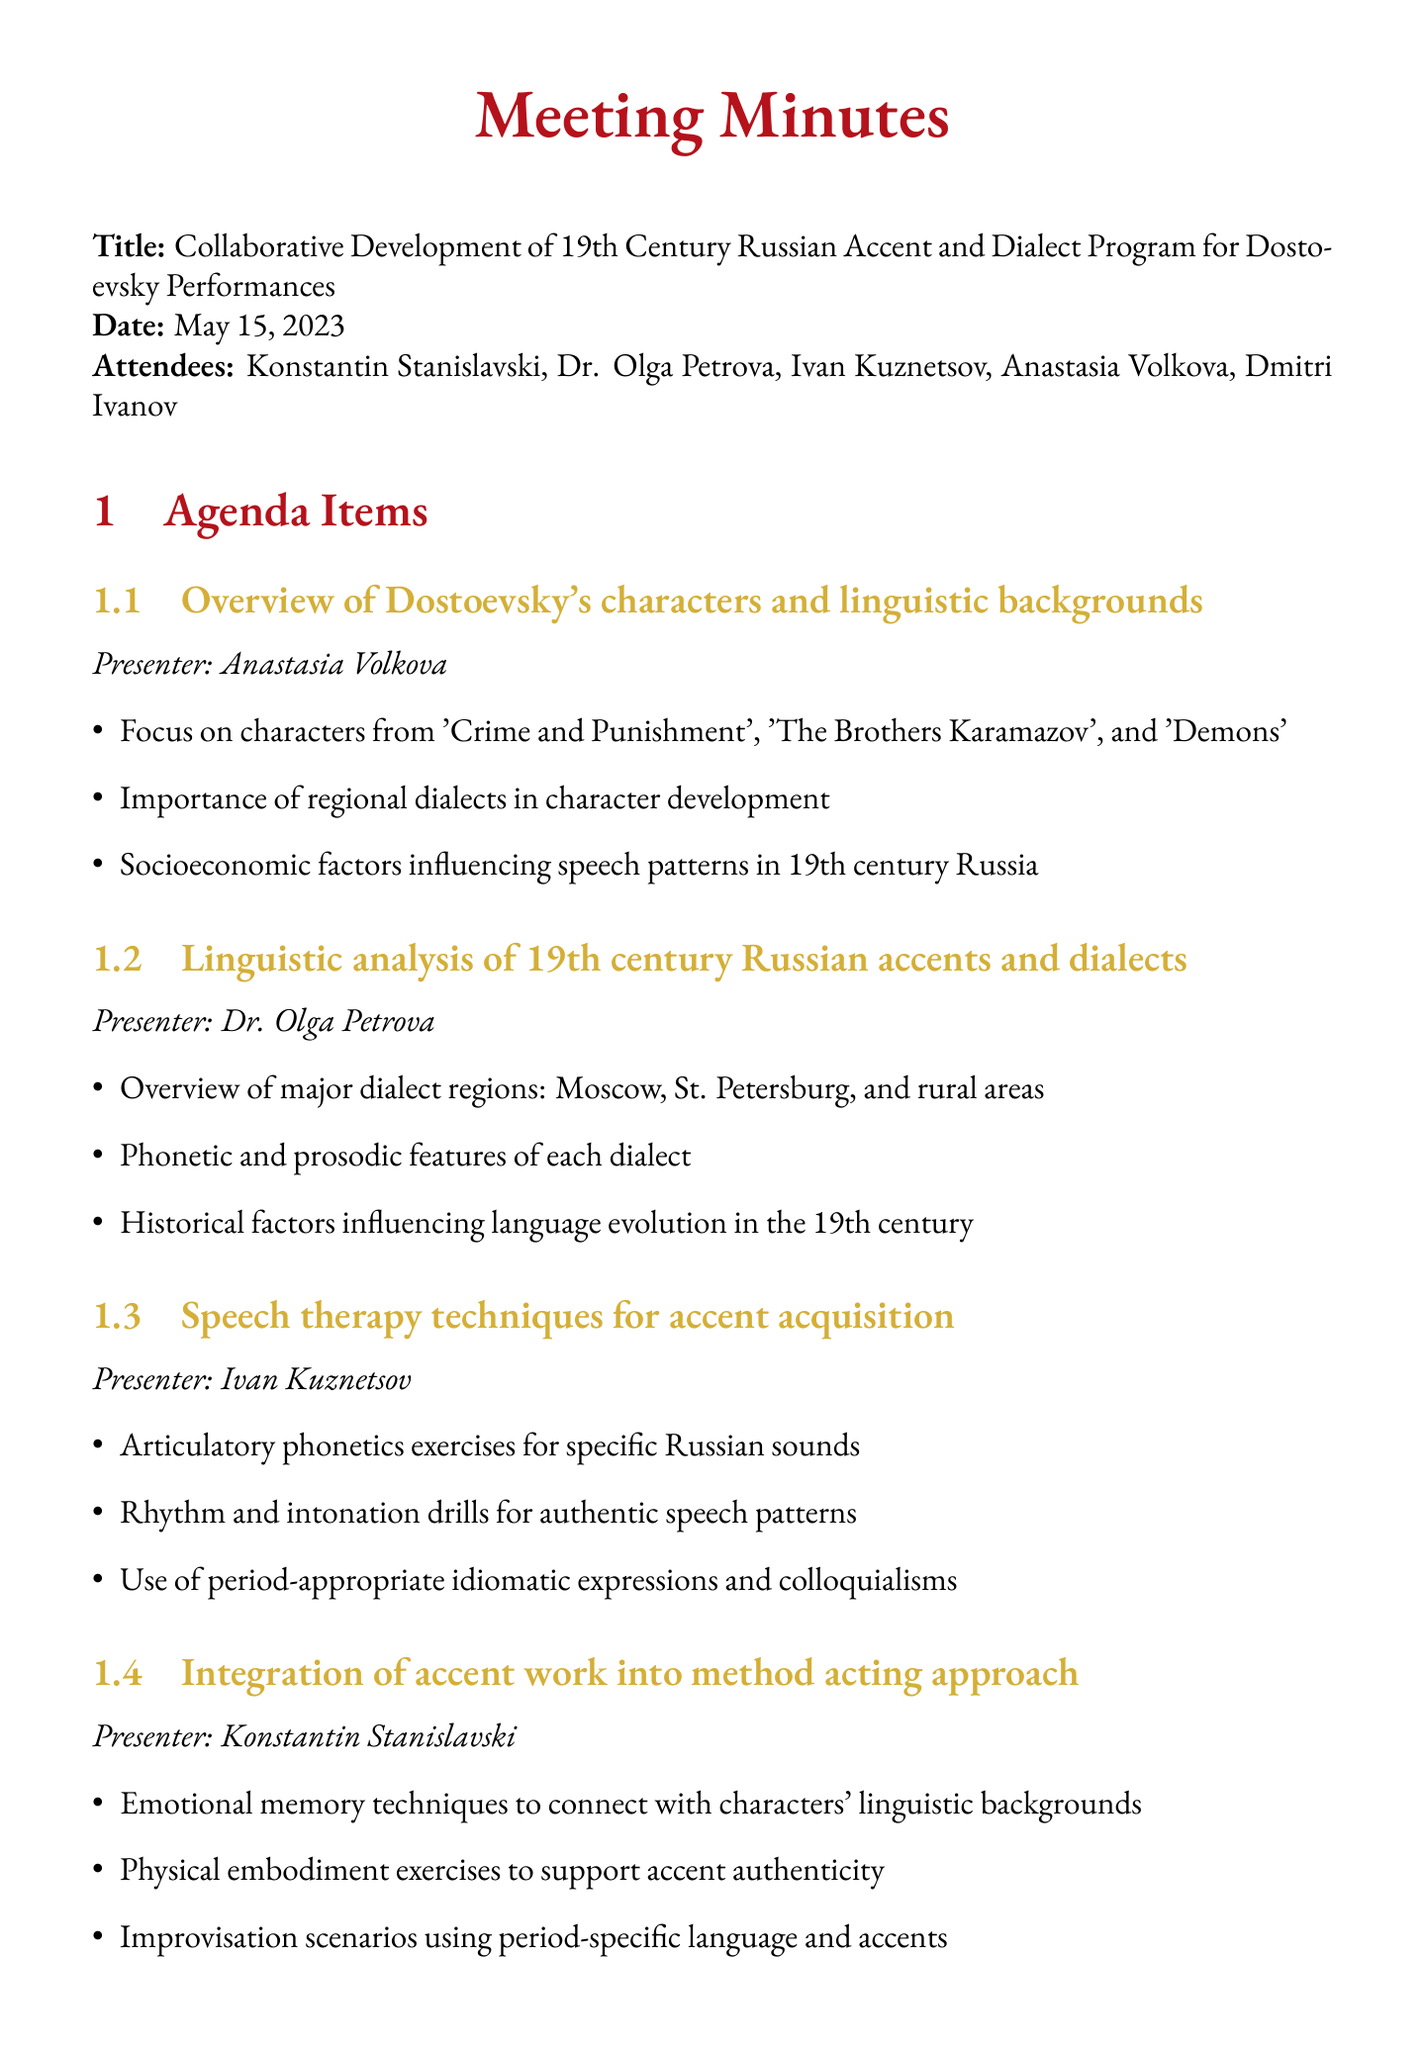What is the title of the meeting? The title is specifically stated at the beginning of the document.
Answer: Collaborative Development of 19th Century Russian Accent and Dialect Program for Dostoevsky Performances Who presented the overview of Dostoevsky's characters? The presenter's name is directly associated with the topic in the agenda.
Answer: Anastasia Volkova What is the date of the next meeting? The next meeting date is clearly mentioned in the document.
Answer: June 1, 2023 How many attendees were there? The number of attendees can be counted from the attendees list provided in the document.
Answer: Five Which character from Dostoevsky's works was mentioned? The agenda items refer to specific works by Dostoevsky indicating character relevance.
Answer: Crime and Punishment What is one action item discussed in the meeting? Action items are listed at the end of the document, summarizing next steps.
Answer: Develop a comprehensive dialect map for Dostoevsky's major works Who specialized in linguistics in the 19th century Russian context? This information is based on the roles and expertise of the attendees listed.
Answer: Dr. Olga Petrova What dialect regions were discussed in the linguistic analysis? The relevant information is highlighted under the linguistic analysis section.
Answer: Moscow, St. Petersburg, and rural areas 